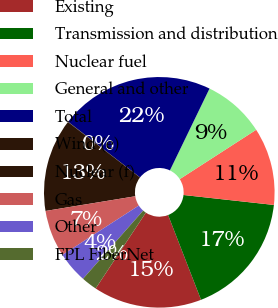Convert chart. <chart><loc_0><loc_0><loc_500><loc_500><pie_chart><fcel>Existing<fcel>Transmission and distribution<fcel>Nuclear fuel<fcel>General and other<fcel>Total<fcel>Wind (e)<fcel>Nuclear (f)<fcel>Gas<fcel>Other<fcel>FPL FiberNet<nl><fcel>15.2%<fcel>17.36%<fcel>10.87%<fcel>8.7%<fcel>21.69%<fcel>0.04%<fcel>13.03%<fcel>6.54%<fcel>4.37%<fcel>2.2%<nl></chart> 